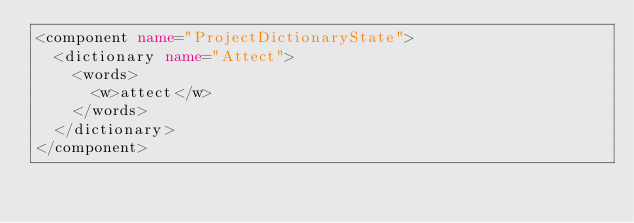<code> <loc_0><loc_0><loc_500><loc_500><_XML_><component name="ProjectDictionaryState">
  <dictionary name="Attect">
    <words>
      <w>attect</w>
    </words>
  </dictionary>
</component></code> 